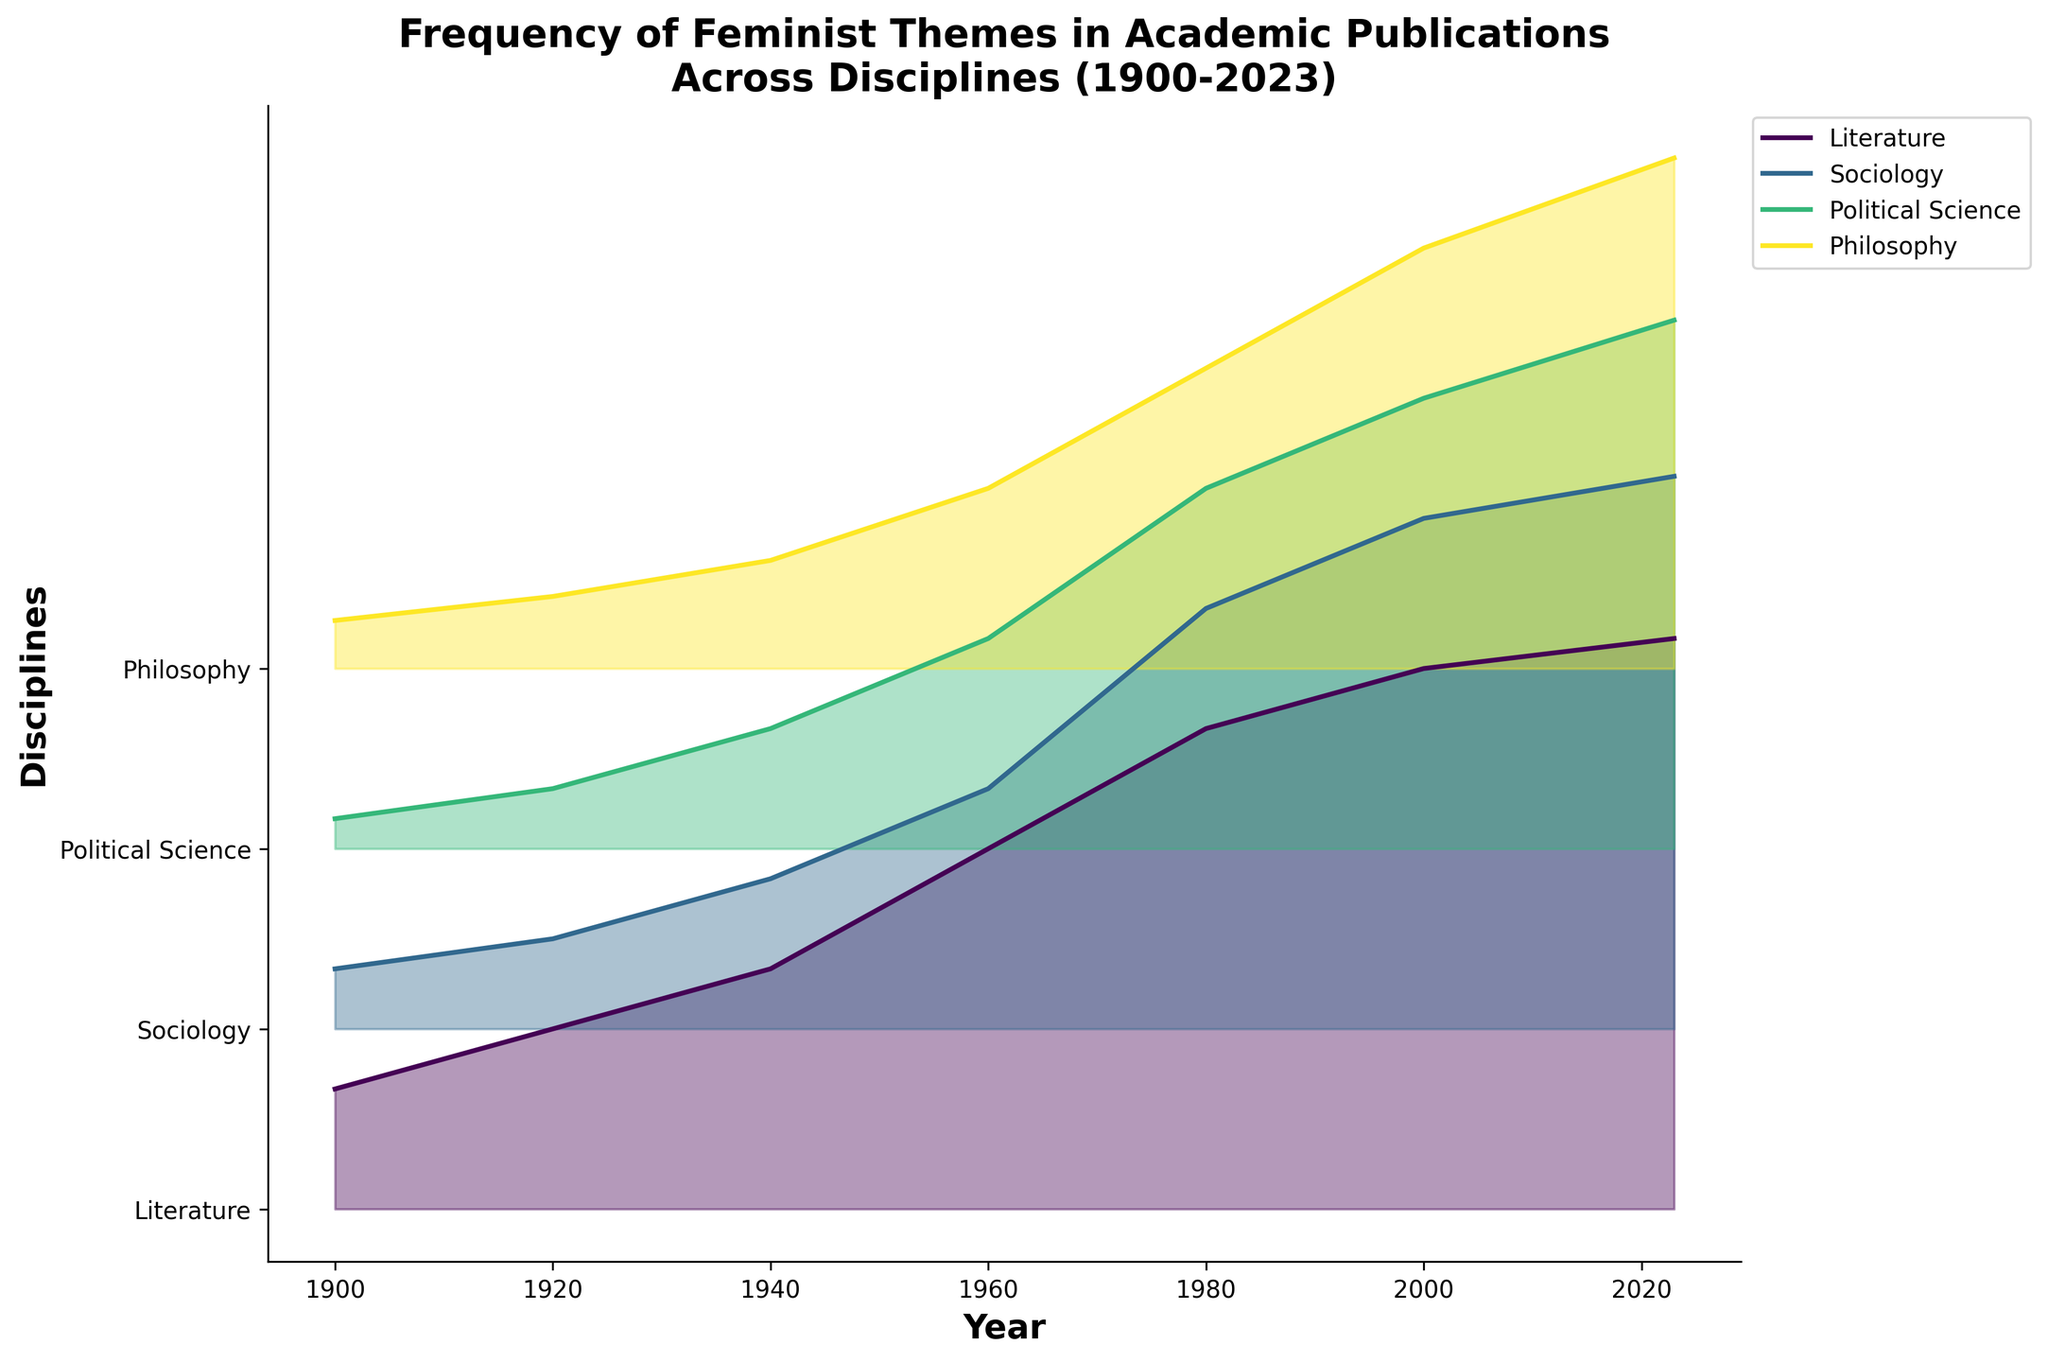What is the title of the plot? The title of the plot is located at the top of the figure and can be easily identified by reading the text.
Answer: Frequency of Feminist Themes in Academic Publications Across Disciplines (1900-2023) What are the labels on the X and Y axes? The X-axis and Y-axis labels provide information on what is represented on each axis. The X-axis label is below the horizontal axis, and the Y-axis label is next to the vertical axis.
Answer: X-axis: Year, Y-axis: Disciplines Which discipline shows the highest frequency of feminist themes in the year 2023? To determine the highest frequency in 2023, look at the topmost lines on the rightmost side of the plot, which represents the year 2023. Compare the heights of the ridgelines to see which one is at the highest position.
Answer: Literature How has the frequency of feminist themes in Sociology changed from 1960 to 2000? To observe the changes, compare the heights of the ridgeline corresponding to Sociology in 1960 and 2000. Look at the Y-axis labels to find Sociology and then examine the peaks at the years 1960 and 2000.
Answer: Increased from 0.4 to 0.85 Between which two consecutive periods did Political Science exhibit the greatest increase in frequency? Compare the differences in the heights of the ridgelines for Political Science between consecutive periods. Identify the segment with the steepest upward slope.
Answer: 1940 to 1960 Which discipline had the lowest frequency of feminist themes in 1900? Find the year 1900 on the plot's X-axis, and observe the ridgelines to see which discipline's line is the lowest for that year.
Answer: Political Science How does the frequency of feminist themes in Philosophy in 1920 compare to that in Literature in 1940? Identify the ridgelines for Philosophy in 1920 and Literature in 1940. Compare their heights to see which one is higher.
Answer: Philosophy in 1920 is lower than Literature in 1940 What is the average frequency of feminist themes in Literature over the years 1900, 1920, and 1940? Sum the frequencies of feminist themes in Literature for the years 1900, 1920, and 1940, and then divide by 3.
Answer: (0.2 + 0.3 + 0.4) / 3 = 0.3 By how much did the frequency of feminist themes in Philosophy increase from 1940 to 2023? Calculate the difference between the frequency values of Philosophy in 1940 and 2023 by subtracting the 1940 value from the 2023 value.
Answer: 0.85 - 0.18 = 0.67 Which two disciplines have the closest frequencies of feminist themes in 1980? Compare the ridgelines for all disciplines in 1980 and find the two lines that are nearest to each other in height.
Answer: Political Science and Philosophy 